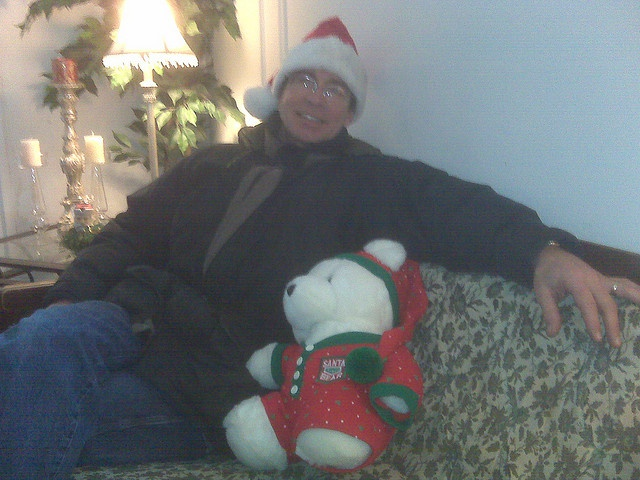Describe the objects in this image and their specific colors. I can see people in darkgray, black, gray, and blue tones, couch in darkgray, gray, and purple tones, teddy bear in darkgray, gray, teal, and brown tones, and potted plant in darkgray, tan, ivory, and gray tones in this image. 